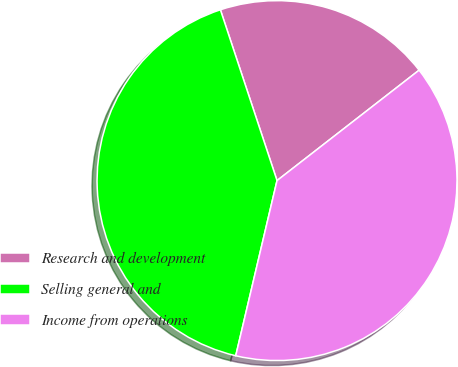Convert chart to OTSL. <chart><loc_0><loc_0><loc_500><loc_500><pie_chart><fcel>Research and development<fcel>Selling general and<fcel>Income from operations<nl><fcel>19.58%<fcel>41.22%<fcel>39.2%<nl></chart> 